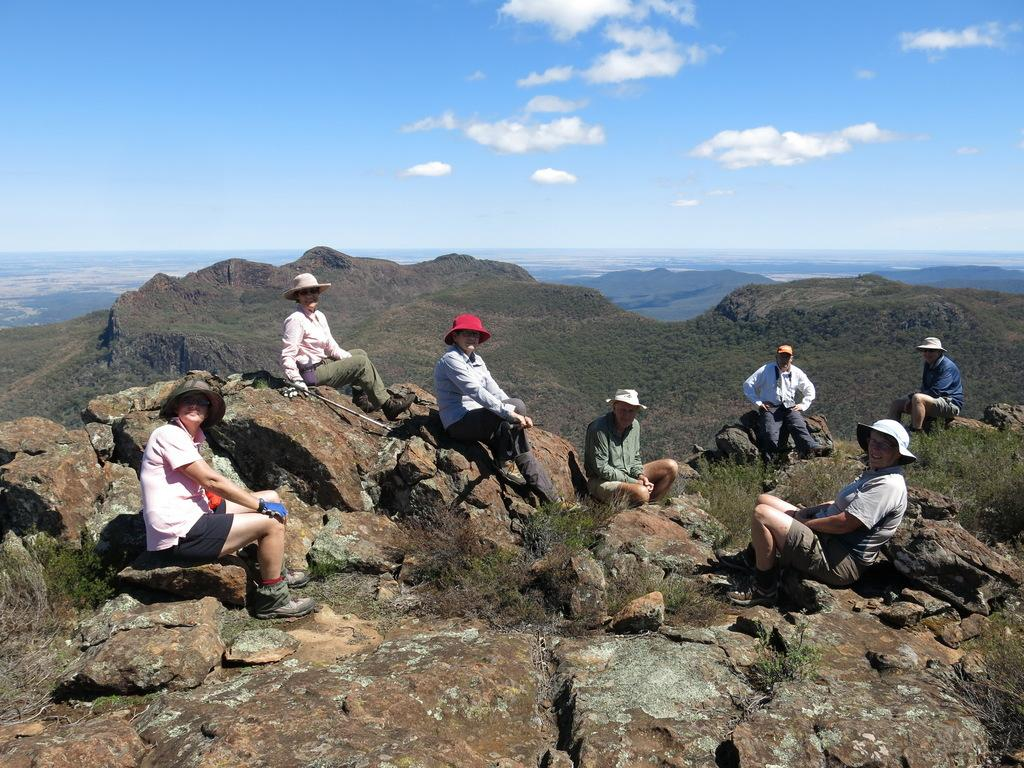What type of location is depicted in the image? The image depicts a hill station. What natural features can be seen in the image? There are large rocks in the image. What are the people in the image doing? People are sitting on the rocks. What can be seen in the distance in the image? There are small mountains in the background. What is visible in the sky in the image? The sky is visible in the background. What type of letter is being written on the wax in the image? There is no letter or wax present in the image; it features a hill station with people sitting on rocks and a background of small mountains and sky. 